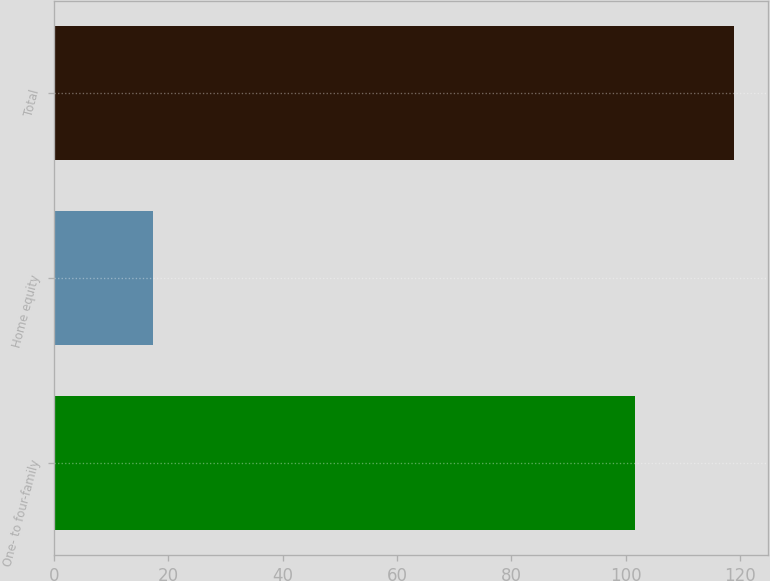<chart> <loc_0><loc_0><loc_500><loc_500><bar_chart><fcel>One- to four-family<fcel>Home equity<fcel>Total<nl><fcel>101.7<fcel>17.3<fcel>119<nl></chart> 